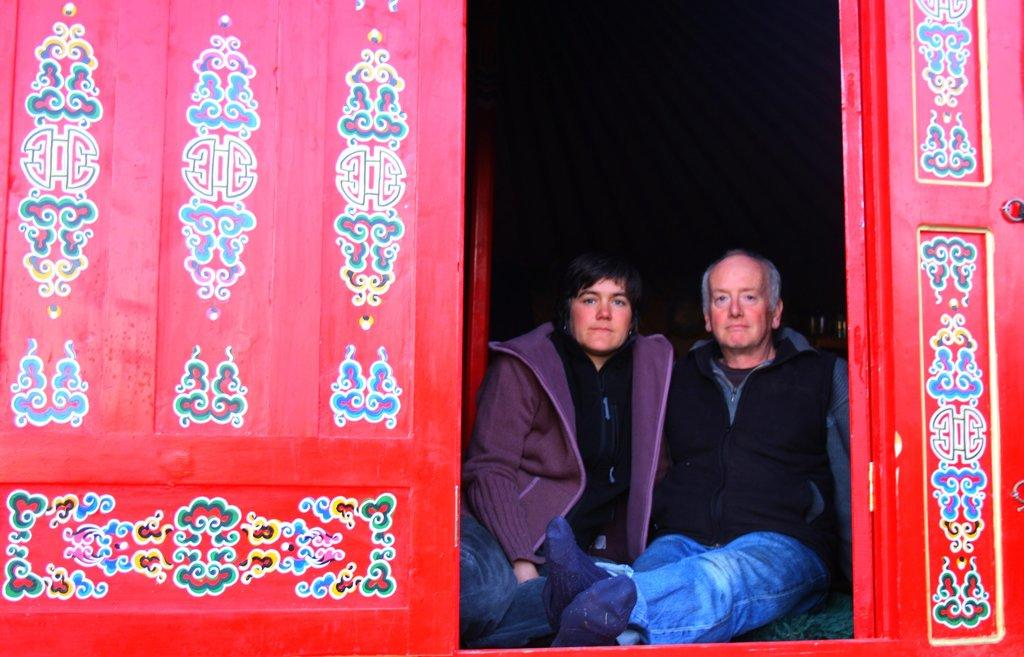How many people are present in the image? There is a man and a woman in the image. What are the man and woman doing in the image? The man and woman are sitting on a surface. What can be seen on the wall in the image? There is a painting on a wall in the image. What architectural feature is visible in the image? There is a door in the image. What time of day is it in the image, and how do we know it's morning? The time of day is not mentioned or indicated in the image, and there is no information to suggest it's morning. Can you tell me how many slaves are present in the image? There are no slaves present in the image; it features a man and a woman sitting together. 